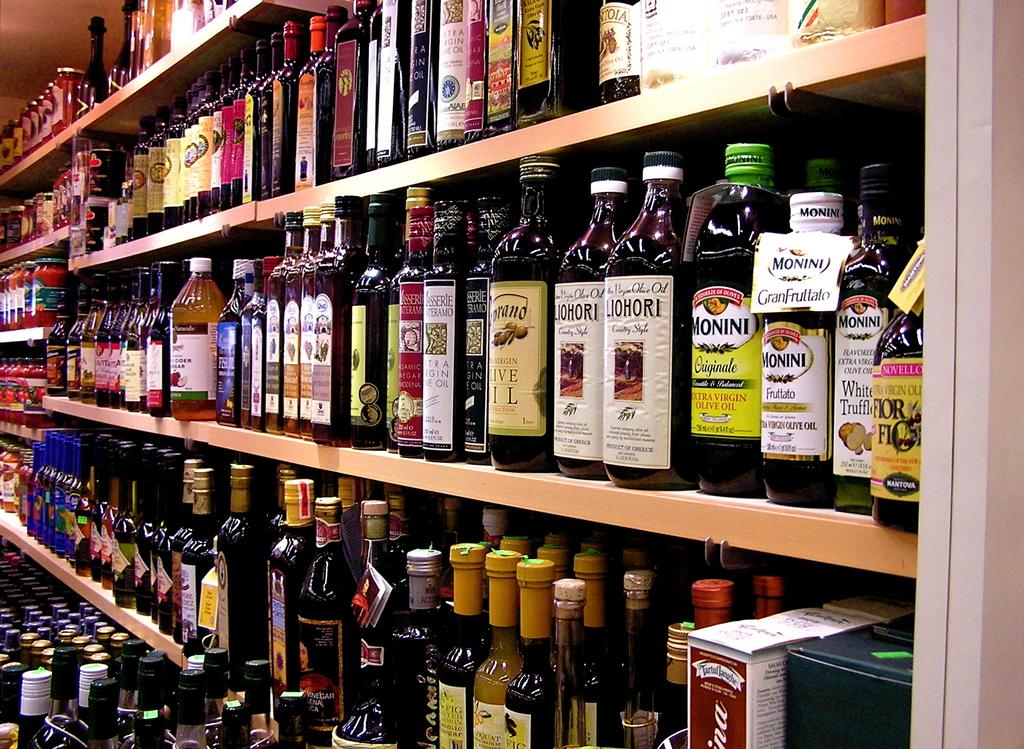What can be seen on the shelves in the image? The shelves have bottles arranged on them. How many shelves are visible in the image? The provided facts do not specify the number of shelves, so we cannot definitively answer this question. What type of country is depicted on the wall in the image? There is no country or wall present in the image; it only features shelves with bottles arranged on them. 